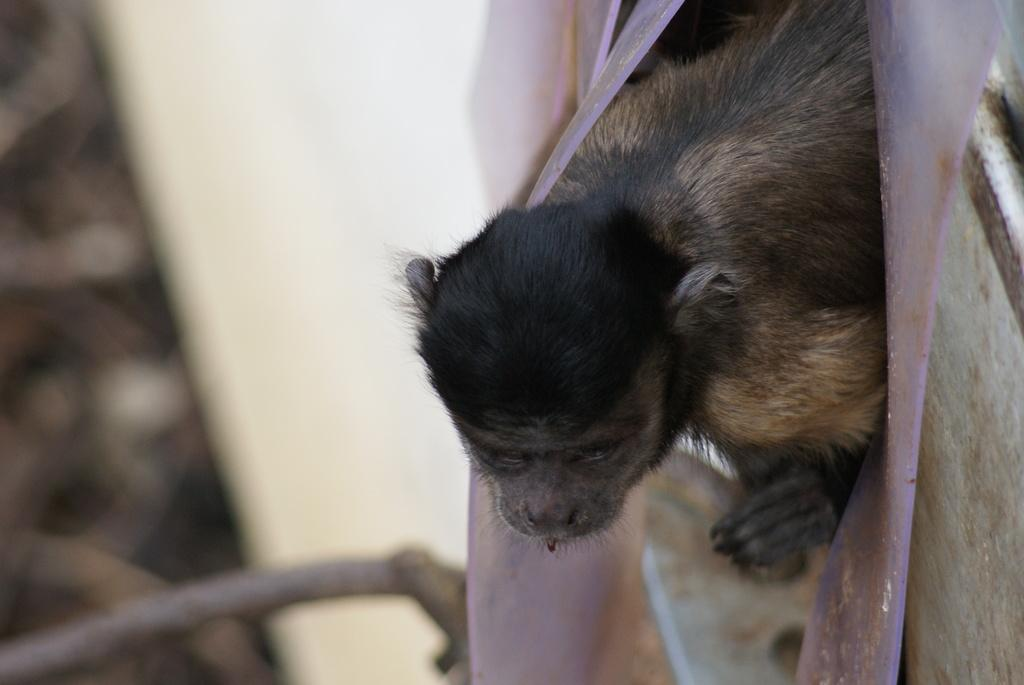What type of animal is present in the image? There is an animal in the image, but its specific type cannot be determined from the provided facts. What can be seen on the right side of the image? There are white objects on the right side of the image. How would you describe the view on the left side of the image? The view on the left side of the image is blurry. What type of substance is being drained from the fowl in the image? There is no fowl or substance being drained in the image; it only contains an animal and white objects on the right side with a blurry view on the left side. 